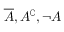<formula> <loc_0><loc_0><loc_500><loc_500>{ \overline { A } } , A ^ { \complement } , \neg A</formula> 